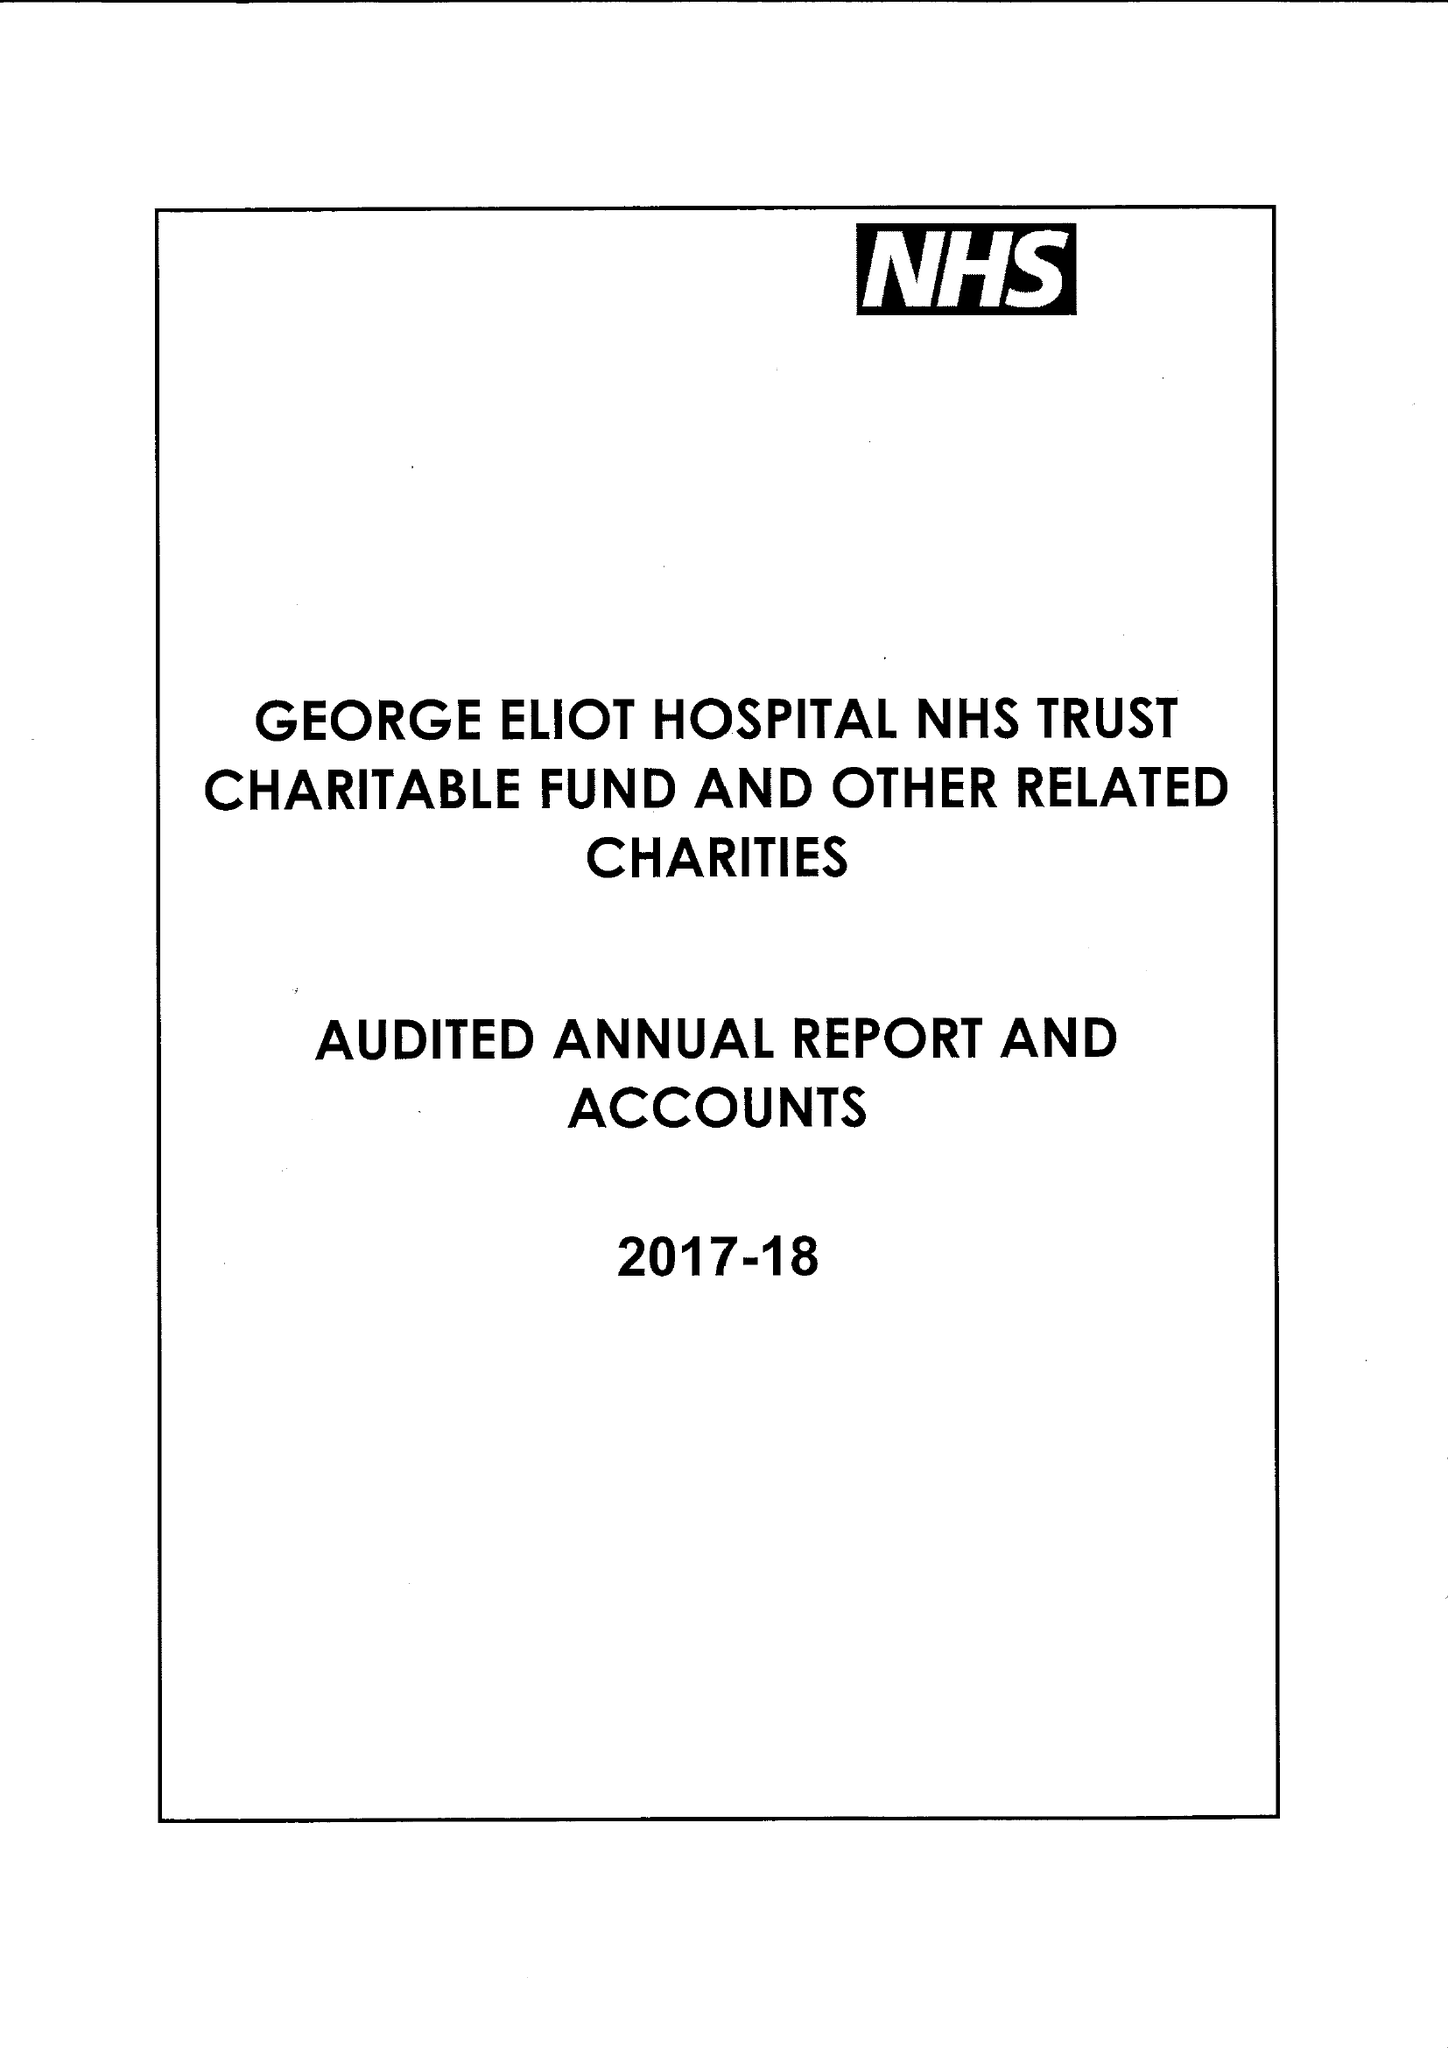What is the value for the income_annually_in_british_pounds?
Answer the question using a single word or phrase. 300000.00 